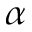<formula> <loc_0><loc_0><loc_500><loc_500>\alpha</formula> 